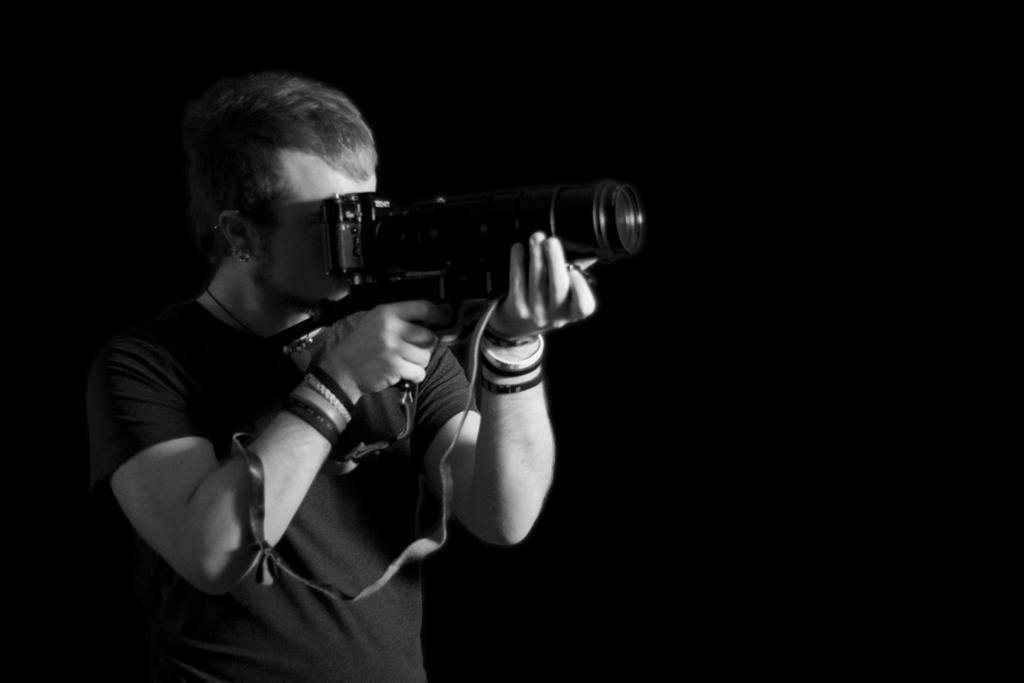In one or two sentences, can you explain what this image depicts? Background is completely dark. This is a black and white picture and we can see one man standing and holding a camera in his hand and recording. He wore wrist band to his both hands. 